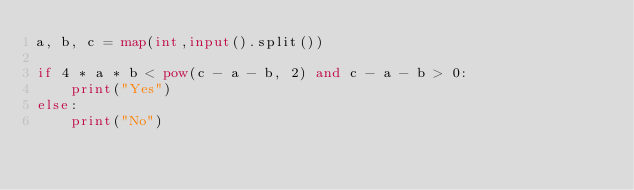Convert code to text. <code><loc_0><loc_0><loc_500><loc_500><_Python_>a, b, c = map(int,input().split())

if 4 * a * b < pow(c - a - b, 2) and c - a - b > 0:
    print("Yes")
else:
    print("No")
</code> 